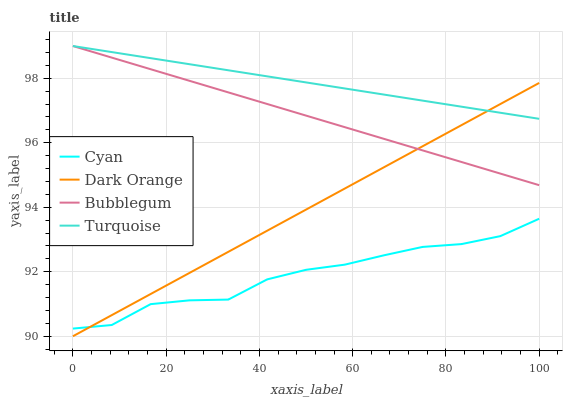Does Cyan have the minimum area under the curve?
Answer yes or no. Yes. Does Turquoise have the maximum area under the curve?
Answer yes or no. Yes. Does Bubblegum have the minimum area under the curve?
Answer yes or no. No. Does Bubblegum have the maximum area under the curve?
Answer yes or no. No. Is Turquoise the smoothest?
Answer yes or no. Yes. Is Cyan the roughest?
Answer yes or no. Yes. Is Bubblegum the smoothest?
Answer yes or no. No. Is Bubblegum the roughest?
Answer yes or no. No. Does Dark Orange have the lowest value?
Answer yes or no. Yes. Does Bubblegum have the lowest value?
Answer yes or no. No. Does Bubblegum have the highest value?
Answer yes or no. Yes. Does Dark Orange have the highest value?
Answer yes or no. No. Is Cyan less than Turquoise?
Answer yes or no. Yes. Is Turquoise greater than Cyan?
Answer yes or no. Yes. Does Turquoise intersect Dark Orange?
Answer yes or no. Yes. Is Turquoise less than Dark Orange?
Answer yes or no. No. Is Turquoise greater than Dark Orange?
Answer yes or no. No. Does Cyan intersect Turquoise?
Answer yes or no. No. 